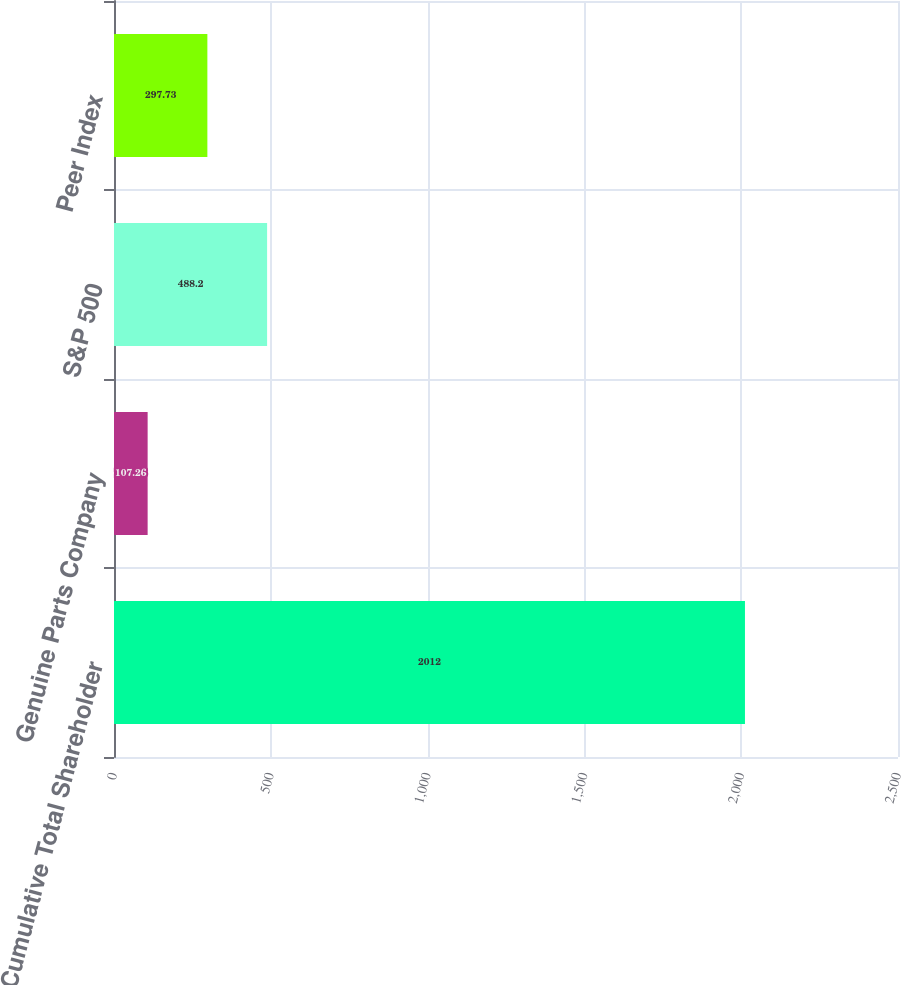<chart> <loc_0><loc_0><loc_500><loc_500><bar_chart><fcel>Cumulative Total Shareholder<fcel>Genuine Parts Company<fcel>S&P 500<fcel>Peer Index<nl><fcel>2012<fcel>107.26<fcel>488.2<fcel>297.73<nl></chart> 